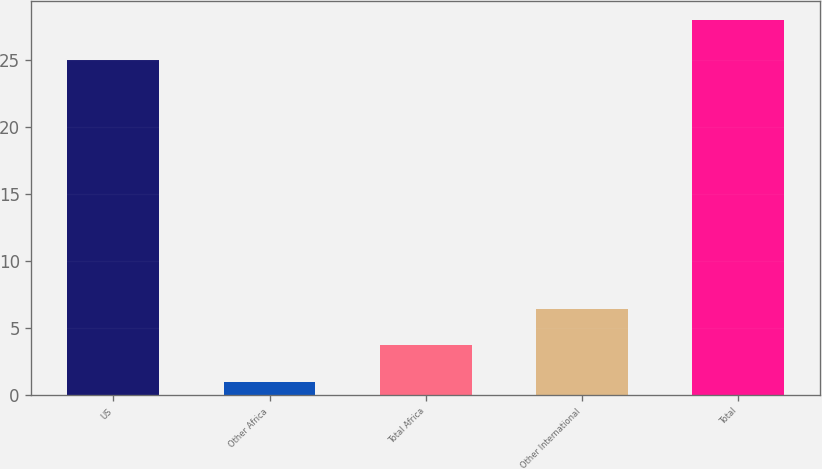Convert chart to OTSL. <chart><loc_0><loc_0><loc_500><loc_500><bar_chart><fcel>US<fcel>Other Africa<fcel>Total Africa<fcel>Other International<fcel>Total<nl><fcel>25<fcel>1<fcel>3.7<fcel>6.4<fcel>28<nl></chart> 